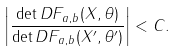<formula> <loc_0><loc_0><loc_500><loc_500>\left | \frac { \det { D F _ { a , b } ( X , \theta ) } } { \det { D F _ { a , b } ( X ^ { \prime } , \theta ^ { \prime } ) } } \right | < C .</formula> 